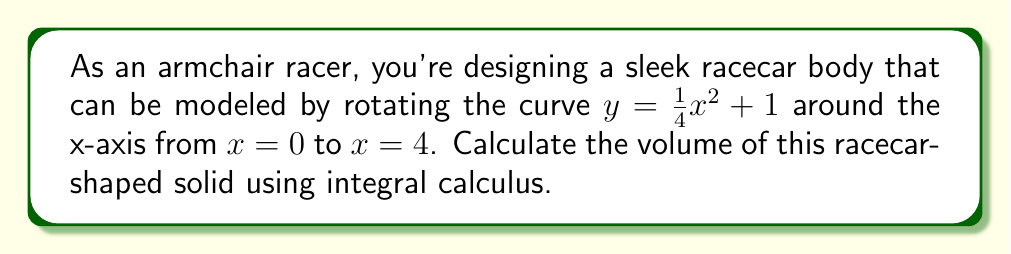Could you help me with this problem? To calculate the volume of a solid formed by rotating a curve around the x-axis, we use the washer method from integral calculus. The formula for this method is:

$$V = \pi \int_a^b [f(x)]^2 dx$$

Where $f(x)$ is the function being rotated, and $a$ and $b$ are the limits of integration.

In this case:
$f(x) = \frac{1}{4}x^2 + 1$
$a = 0$
$b = 4$

Let's solve step-by-step:

1) Substitute into the volume formula:
   $$V = \pi \int_0^4 [\frac{1}{4}x^2 + 1]^2 dx$$

2) Expand the squared term:
   $$V = \pi \int_0^4 [\frac{1}{16}x^4 + \frac{1}{2}x^2 + 1] dx$$

3) Integrate each term:
   $$V = \pi [\frac{1}{16} \cdot \frac{x^5}{5} + \frac{1}{2} \cdot \frac{x^3}{3} + x]_0^4$$

4) Evaluate the integral from 0 to 4:
   $$V = \pi [(\frac{1}{16} \cdot \frac{4^5}{5} + \frac{1}{2} \cdot \frac{4^3}{3} + 4) - (0 + 0 + 0)]$$

5) Simplify:
   $$V = \pi [\frac{256}{80} + \frac{32}{3} + 4]$$
   $$V = \pi [3.2 + 10.67 + 4]$$
   $$V = \pi [17.87]$$
   $$V \approx 56.13$$

Therefore, the volume of the racecar-shaped solid is approximately 56.13 cubic units.
Answer: $56.13$ cubic units 